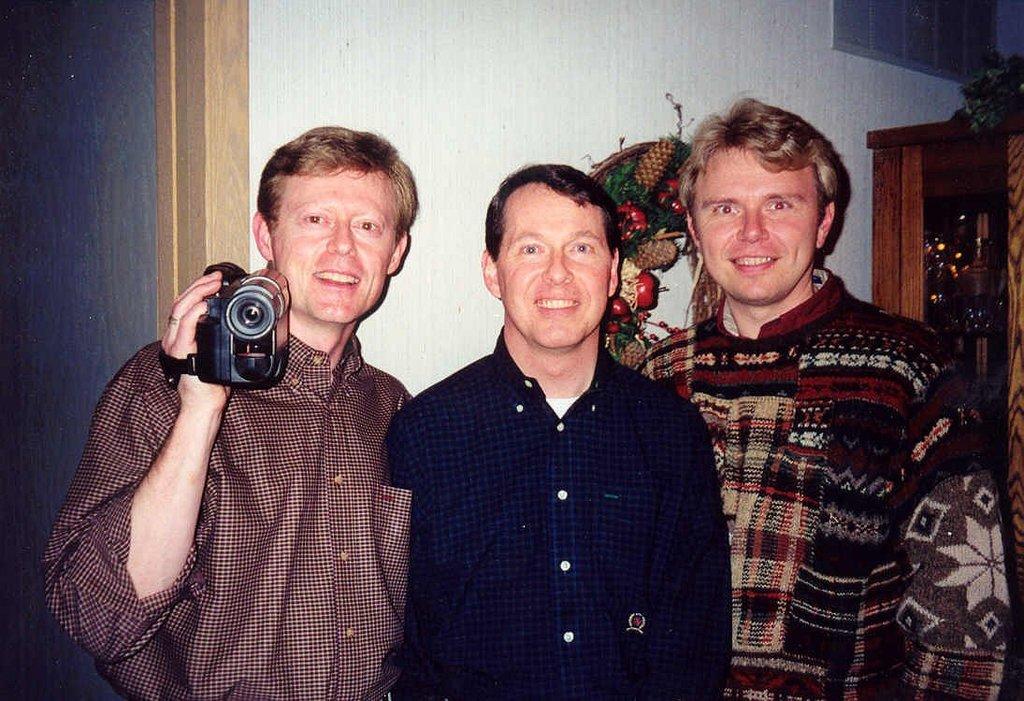How would you summarize this image in a sentence or two? There are three persons standing and smiling. One person is holding a camera recorder. At background I can see some object attached to the wall. At the right side it looks like a wardrobe. 